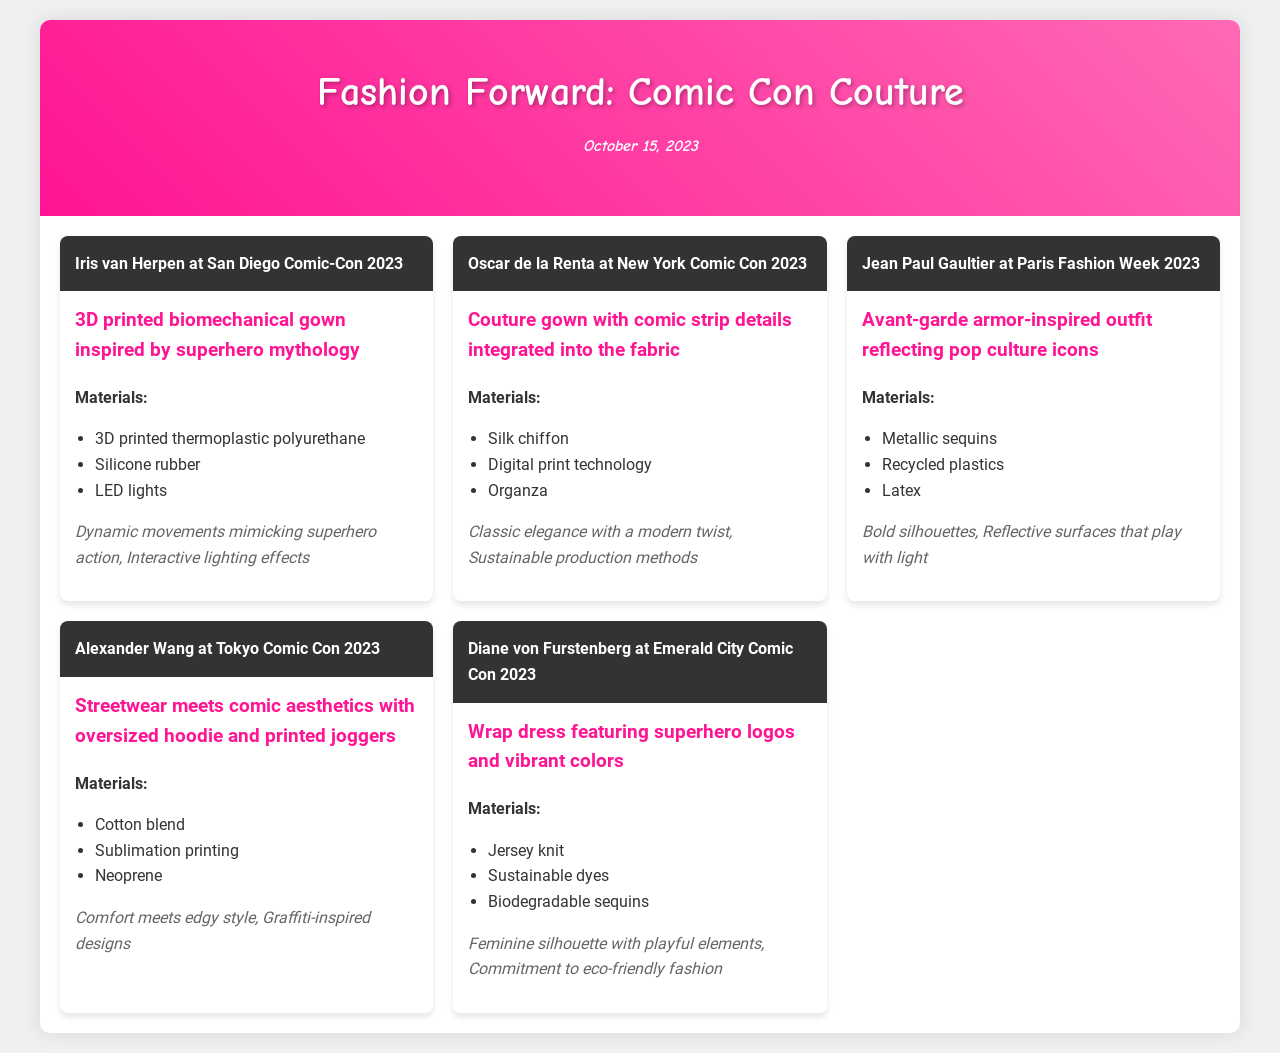What outfit did Iris van Herpen present? The document states that Iris van Herpen presented a 3D printed biomechanical gown inspired by superhero mythology.
Answer: 3D printed biomechanical gown inspired by superhero mythology What materials were used in Oscar de la Renta's outfit? The materials listed for Oscar de la Renta's gown include silk chiffon, digital print technology, and organza.
Answer: Silk chiffon, digital print technology, organza Which designer used recycled plastics in their outfit? In the document, Jean Paul Gaultier's outfit mentions the use of recycled plastics.
Answer: Jean Paul Gaultier What notable feature is associated with Alexander Wang's design? The document highlights that Alexander Wang's outfit features graffiti-inspired designs as a notable feature.
Answer: Graffiti-inspired designs How many designers' outfits are featured in the document? To find the number of designers, we count the number of distinct designer cards presented, which totals five.
Answer: Five 